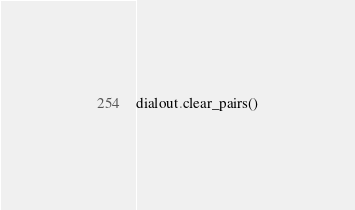Convert code to text. <code><loc_0><loc_0><loc_500><loc_500><_Python_>
dialout.clear_pairs()</code> 